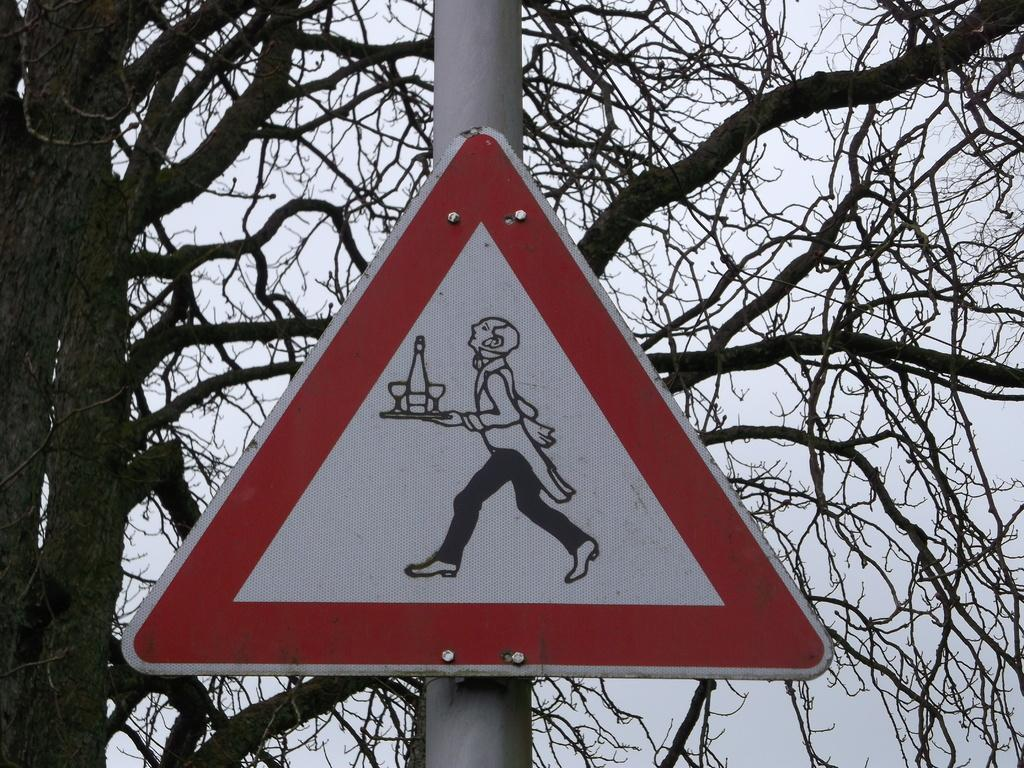What is the main object in the center of the image? There is a sign board in the center of the image. How is the sign board supported or attached? The sign board is attached to a pole. What can be seen in the background of the image? There is a tree visible in the background of the image. Is there a park or prison visible in the image? There is no park or prison visible in the image; only a sign board, a pole, and a tree are present. What type of base is supporting the sign board in the image? The sign board is attached to a pole, not a base, in the image. 